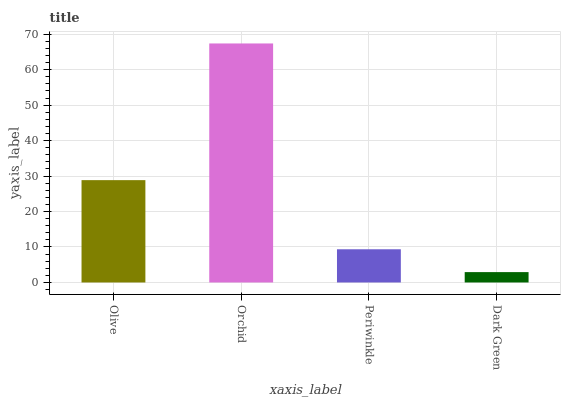Is Periwinkle the minimum?
Answer yes or no. No. Is Periwinkle the maximum?
Answer yes or no. No. Is Orchid greater than Periwinkle?
Answer yes or no. Yes. Is Periwinkle less than Orchid?
Answer yes or no. Yes. Is Periwinkle greater than Orchid?
Answer yes or no. No. Is Orchid less than Periwinkle?
Answer yes or no. No. Is Olive the high median?
Answer yes or no. Yes. Is Periwinkle the low median?
Answer yes or no. Yes. Is Periwinkle the high median?
Answer yes or no. No. Is Dark Green the low median?
Answer yes or no. No. 